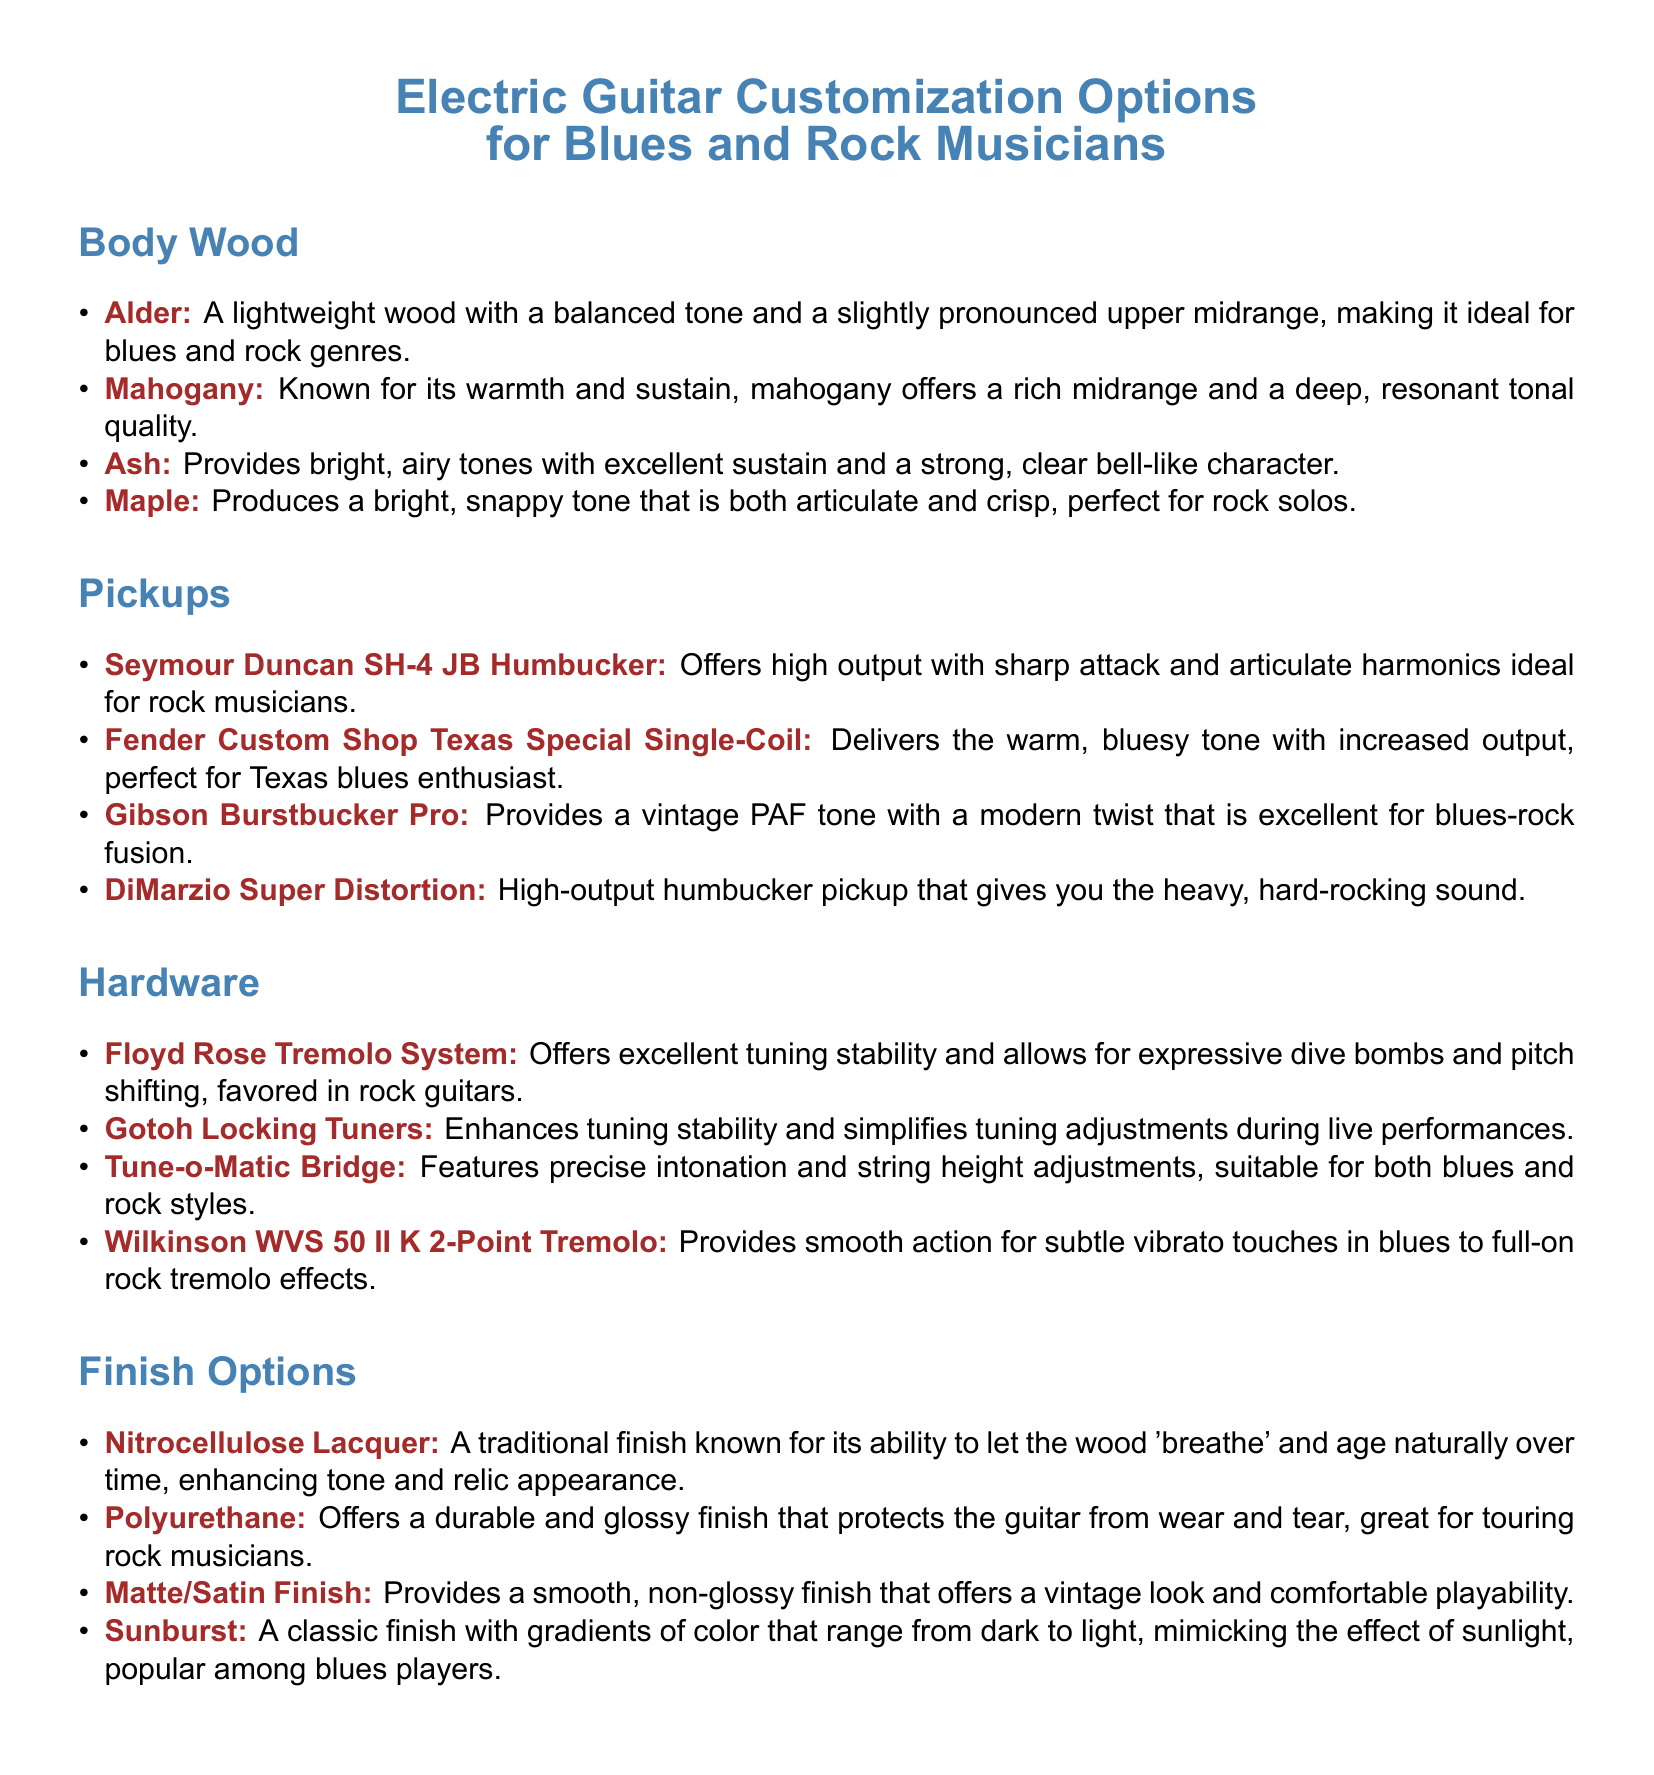What type of body wood is known for its warmth and sustain? The document states that mahogany is known for its warmth and sustain.
Answer: Mahogany Which pickup offers a vintage PAF tone? The Gibson Burstbucker Pro provides a vintage PAF tone with a modern twist.
Answer: Gibson Burstbucker Pro What hardware option is favored in rock guitars for pitch shifting? The Floyd Rose Tremolo System is favored for its ability to allow expressive dive bombs and pitch shifting.
Answer: Floyd Rose Tremolo System What is the finish option that is durable and glossy? The polyurethane finish offers a durable and glossy finish to protect the guitar.
Answer: Polyurethane How many different body wood options are listed? There are four body wood options mentioned in the document.
Answer: Four Which pickup is perfect for Texas blues enthusiasts? The Fender Custom Shop Texas Special Single-Coil is perfect for Texas blues enthusiasts.
Answer: Fender Custom Shop Texas Special Single-Coil What type of bridge features precise intonation and string height adjustments? The Tune-o-Matic Bridge features precise intonation and string height adjustments.
Answer: Tune-o-Matic Bridge What finish option provides a smooth, non-glossy look? The matte/satin finish provides a smooth, non-glossy look.
Answer: Matte/Satin Finish Which body wood provides bright, airy tones? The ash body wood provides bright, airy tones.
Answer: Ash 